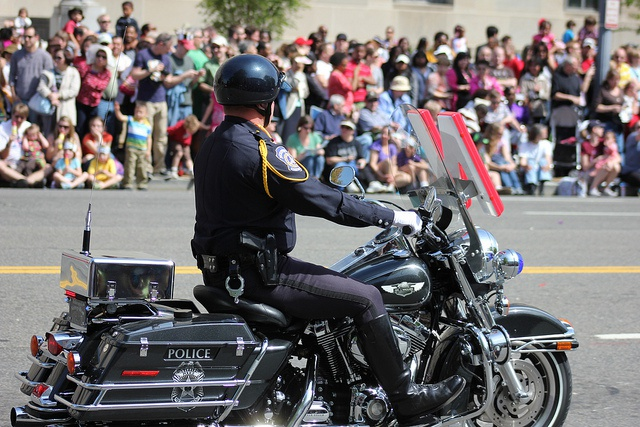Describe the objects in this image and their specific colors. I can see motorcycle in lightgray, black, darkgray, and gray tones, people in lightgray, black, gray, and darkgray tones, people in lightgray, black, and gray tones, people in lightgray, gray, black, and darkgray tones, and people in lightgray, darkgray, gray, darkgreen, and tan tones in this image. 